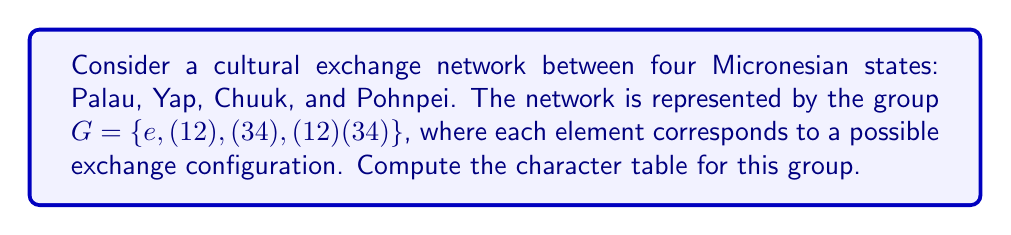What is the answer to this math problem? To compute the character table for the group $G$, we'll follow these steps:

1) First, identify the conjugacy classes:
   $[e] = \{e\}$
   $[(12)] = \{(12), (34)\}$
   $[(12)(34)] = \{(12)(34)\}$

2) The number of irreducible representations equals the number of conjugacy classes, so we have 3 irreducible representations.

3) The dimensions of these representations must satisfy:
   $1^2 + 1^2 + 1^2 = |G| = 4$
   So all representations are 1-dimensional.

4) Let's call these representations $\chi_1, \chi_2, \chi_3$.

5) $\chi_1$ is always the trivial representation, with all characters equal to 1.

6) For $\chi_2$, we know $\chi_2(e) = 1$. Since $(12)^2 = e$, $\chi_2((12))$ must be $\pm 1$. Choose $\chi_2((12)) = -1$.

7) $\chi_2((12)(34)) = \chi_2((12)) \cdot \chi_2((34)) = (-1)(-1) = 1$

8) For $\chi_3$, use orthogonality of columns:
   $\chi_3(e) + \chi_3((12)(34)) = 0$
   $\chi_3(e) = 1$, so $\chi_3((12)(34)) = -1$

9) Use orthogonality again:
   $2\chi_3((12)) + \chi_3((12)(34)) = 0$
   $2\chi_3((12)) - 1 = 0$
   $\chi_3((12)) = \frac{1}{2}$

The character table is thus:

$$
\begin{array}{c|ccc}
G & [e] & [(12)] & [(12)(34)] \\
\hline
\chi_1 & 1 & 1 & 1 \\
\chi_2 & 1 & -1 & 1 \\
\chi_3 & 1 & \frac{1}{2} & -1
\end{array}
$$
Answer: $$
\begin{array}{c|ccc}
G & [e] & [(12)] & [(12)(34)] \\
\hline
\chi_1 & 1 & 1 & 1 \\
\chi_2 & 1 & -1 & 1 \\
\chi_3 & 1 & \frac{1}{2} & -1
\end{array}
$$ 